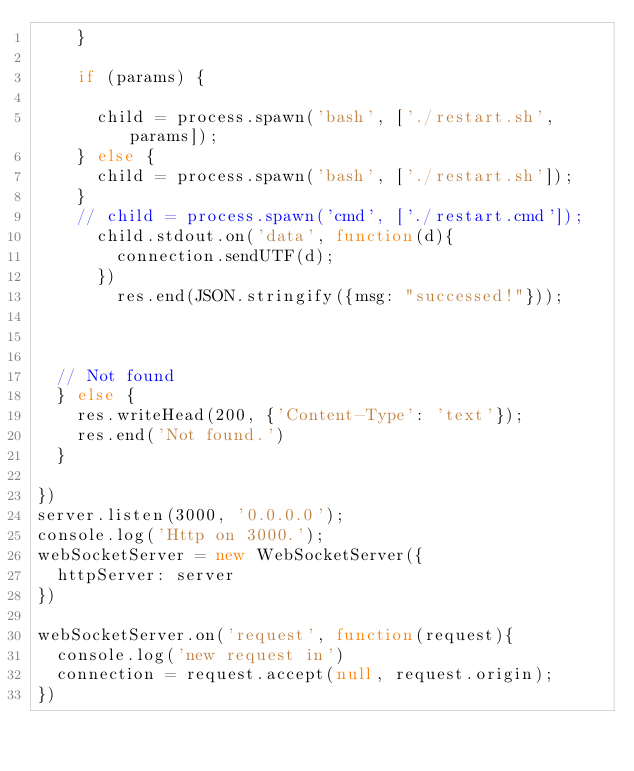Convert code to text. <code><loc_0><loc_0><loc_500><loc_500><_JavaScript_>    }

    if (params) {

      child = process.spawn('bash', ['./restart.sh', params]);
    } else {
      child = process.spawn('bash', ['./restart.sh']);
    }
    // child = process.spawn('cmd', ['./restart.cmd']);
	  child.stdout.on('data', function(d){
	    connection.sendUTF(d);
	  })
		res.end(JSON.stringify({msg: "successed!"}));



  // Not found
  } else {
    res.writeHead(200, {'Content-Type': 'text'});
    res.end('Not found.')
  }

})
server.listen(3000, '0.0.0.0');
console.log('Http on 3000.');
webSocketServer = new WebSocketServer({
  httpServer: server
})

webSocketServer.on('request', function(request){
  console.log('new request in')
  connection = request.accept(null, request.origin);
})
</code> 